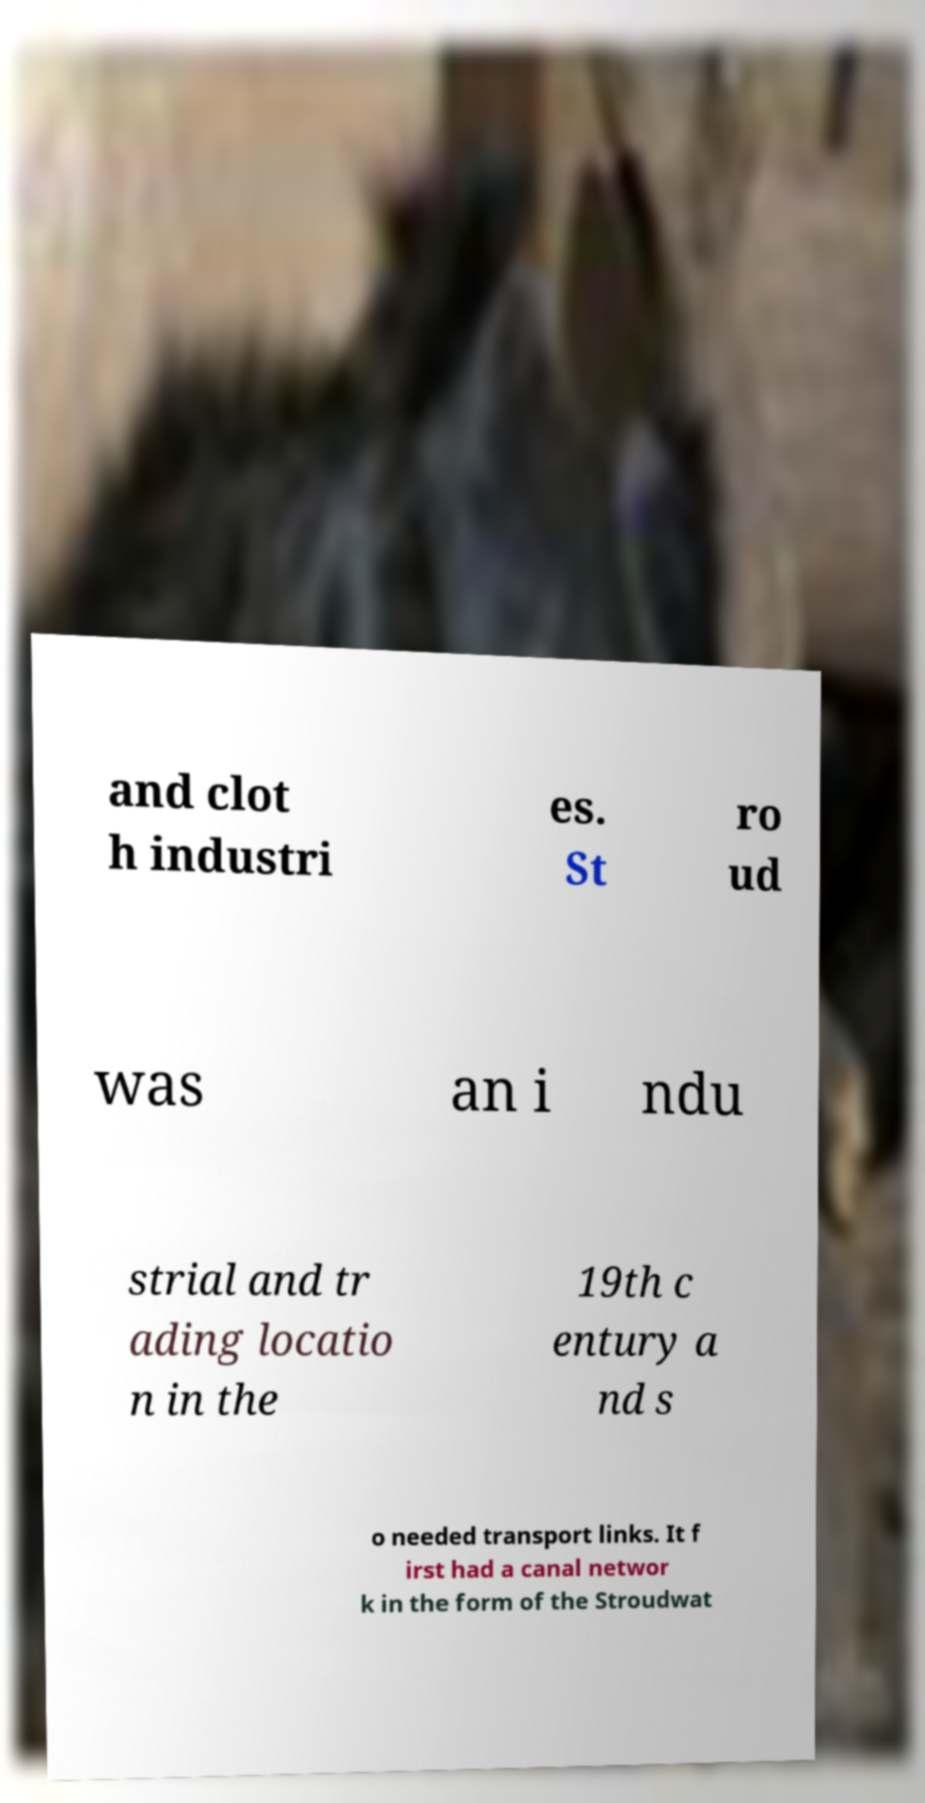There's text embedded in this image that I need extracted. Can you transcribe it verbatim? and clot h industri es. St ro ud was an i ndu strial and tr ading locatio n in the 19th c entury a nd s o needed transport links. It f irst had a canal networ k in the form of the Stroudwat 